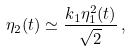<formula> <loc_0><loc_0><loc_500><loc_500>\eta _ { 2 } ( t ) \simeq \frac { k _ { 1 } \eta _ { 1 } ^ { 2 } ( t ) } { \sqrt { 2 } } \, ,</formula> 